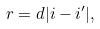Convert formula to latex. <formula><loc_0><loc_0><loc_500><loc_500>r = d | i - i ^ { \prime } | ,</formula> 